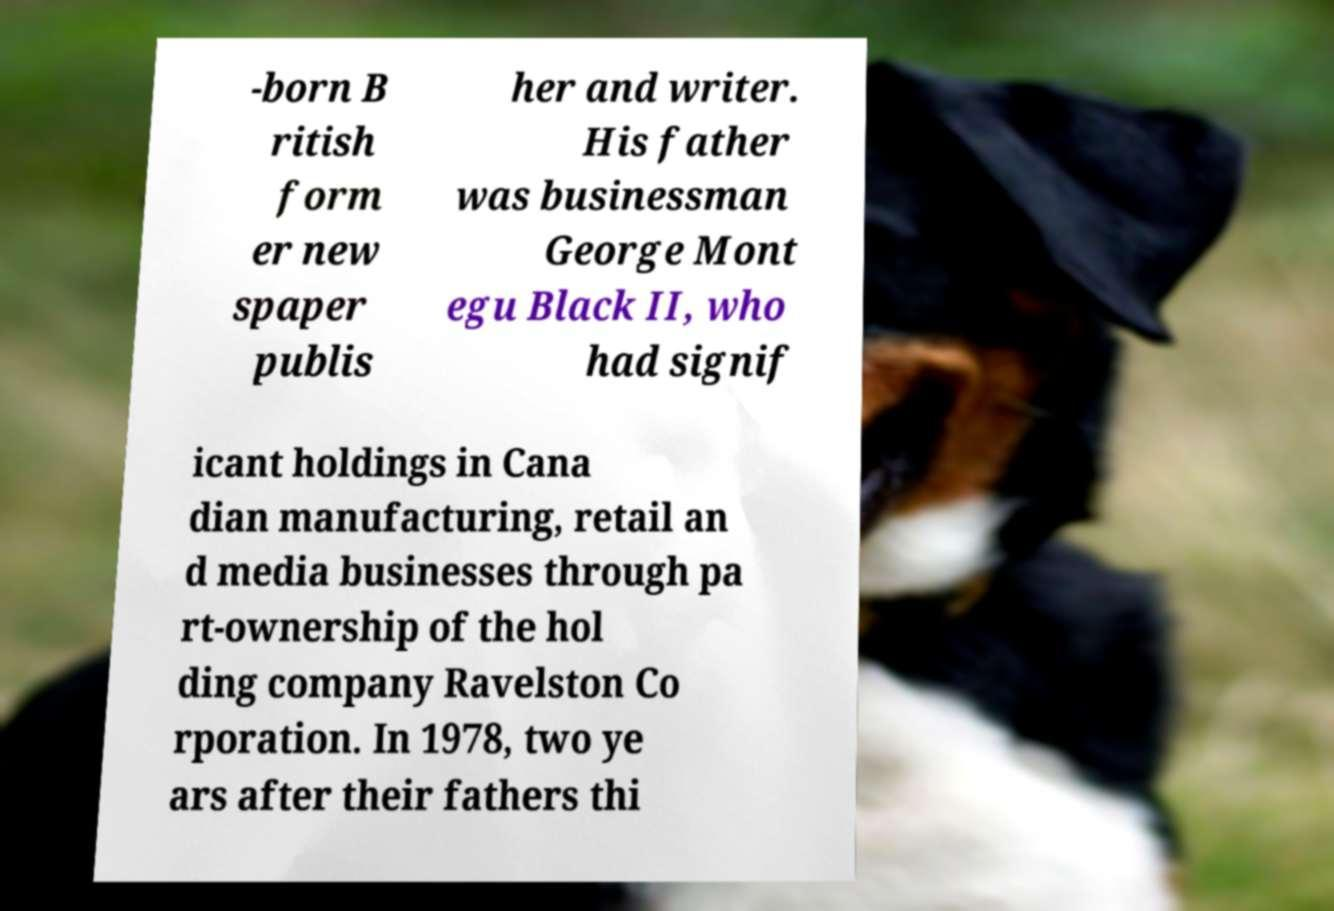There's text embedded in this image that I need extracted. Can you transcribe it verbatim? -born B ritish form er new spaper publis her and writer. His father was businessman George Mont egu Black II, who had signif icant holdings in Cana dian manufacturing, retail an d media businesses through pa rt-ownership of the hol ding company Ravelston Co rporation. In 1978, two ye ars after their fathers thi 